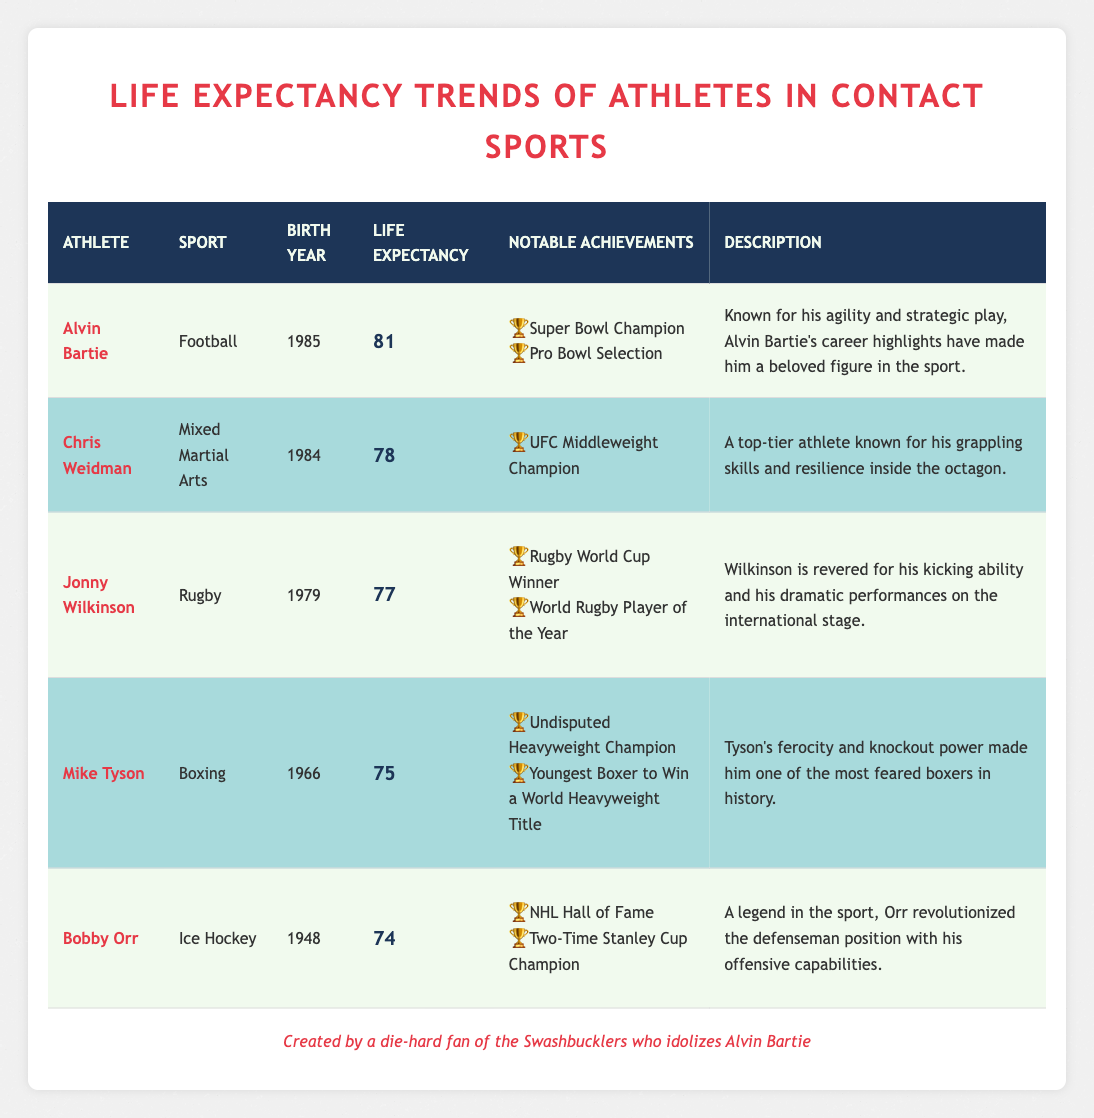What is the life expectancy of Alvin Bartie? Alvin Bartie's life expectancy is listed in the table under the "Life Expectancy" column, which states that it is 81 years.
Answer: 81 Which athlete has the longest life expectancy? The life expectancy column is analyzed, and Alvin Bartie has the highest value at 81 years compared to the others listed, who range from 74 to 78.
Answer: Alvin Bartie How many athletes have a life expectancy of 78 years or more? The athletes with life expectancy of 78 years or more are Alvin Bartie (81), Chris Weidman (78), and Jonny Wilkinson (77). That's a total of three athletes.
Answer: 3 What is the average life expectancy of the athletes listed in the table? To find the average, add each athlete's life expectancy together: 81 + 78 + 77 + 75 + 74 = 385. Then, divide by the number of athletes, which is 5: 385 / 5 = 77.
Answer: 77 Is Mike Tyson's life expectancy higher than Bobby Orr's? By comparing the life expectancies, Mike Tyson's life expectancy is 75 years, while Bobby Orr's life expectancy is 74 years, showing that Mike Tyson's is indeed higher.
Answer: Yes Who has won an award for World Player of the Year among the athletes listed? The table indicates that Jonny Wilkinson has been awarded the title of World Rugby Player of the Year. Thus, he is the only athlete mentioned with this achievement.
Answer: Jonny Wilkinson Does any athlete have a life expectancy lower than 75 years? By looking at the life expectancy values, Bobby Orr (74) and Mike Tyson (75) both have life expectancies that are either lower or at the threshold of 75 years. However, Bobby Orr is the only one strictly below 75.
Answer: Yes Are there more athletes from combat sports or team sports in the table? The table includes 2 combat sports athletes (Chris Weidman, Mike Tyson) and 3 team sports athletes (Alvin Bartie, Jonny Wilkinson, Bobby Orr), which shows there are more team sports athletes.
Answer: Team sports What year was Jonny Wilkinson born? The "Birth Year" column shows Jonny Wilkinson was born in 1979, which answers the question directly.
Answer: 1979 Which athlete is known for his agility and strategic play? The description associated with Alvin Bartie points out his agility and strategic play, thus he is the athlete referred to in the question.
Answer: Alvin Bartie 